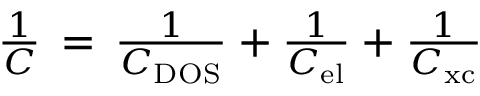Convert formula to latex. <formula><loc_0><loc_0><loc_500><loc_500>\begin{array} { r } { \frac { 1 } { C } \, = \, \frac { 1 } { C _ { D O S } } + \frac { 1 } { C _ { e l } } + \frac { 1 } { C _ { x c } } } \end{array}</formula> 